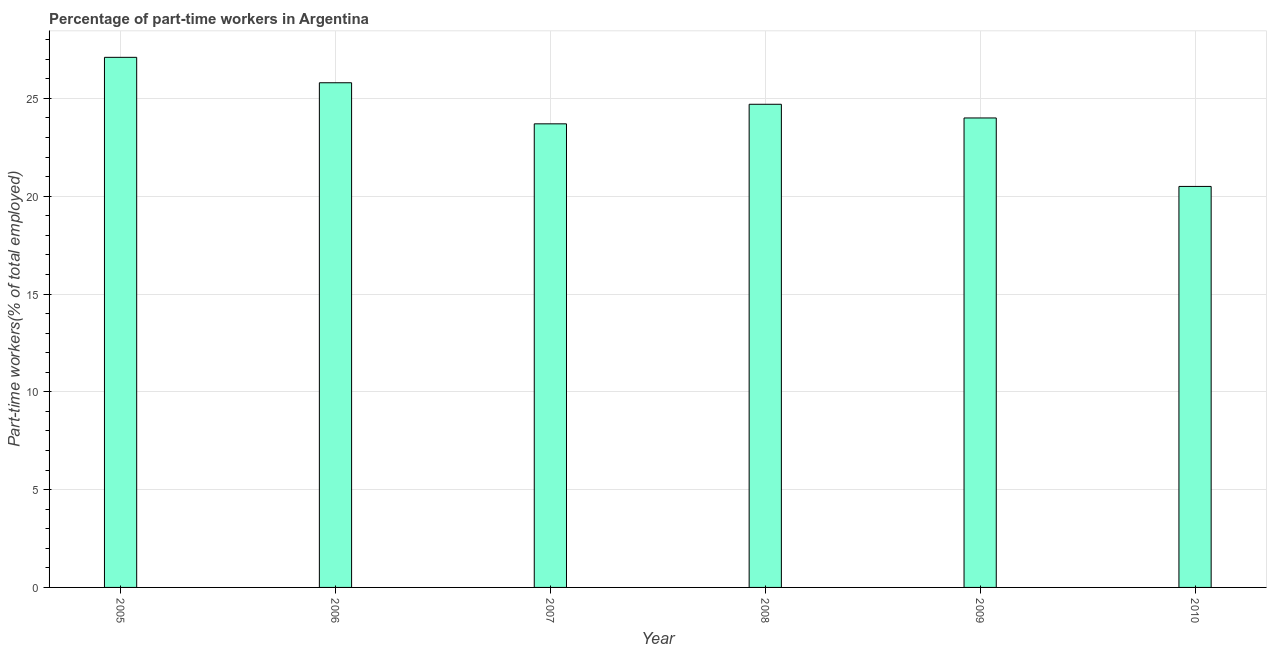Does the graph contain grids?
Make the answer very short. Yes. What is the title of the graph?
Ensure brevity in your answer.  Percentage of part-time workers in Argentina. What is the label or title of the Y-axis?
Offer a terse response. Part-time workers(% of total employed). Across all years, what is the maximum percentage of part-time workers?
Your answer should be very brief. 27.1. Across all years, what is the minimum percentage of part-time workers?
Provide a succinct answer. 20.5. In which year was the percentage of part-time workers maximum?
Give a very brief answer. 2005. In which year was the percentage of part-time workers minimum?
Offer a terse response. 2010. What is the sum of the percentage of part-time workers?
Provide a succinct answer. 145.8. What is the average percentage of part-time workers per year?
Ensure brevity in your answer.  24.3. What is the median percentage of part-time workers?
Make the answer very short. 24.35. In how many years, is the percentage of part-time workers greater than 4 %?
Give a very brief answer. 6. What is the ratio of the percentage of part-time workers in 2006 to that in 2008?
Keep it short and to the point. 1.04. Is the difference between the percentage of part-time workers in 2006 and 2010 greater than the difference between any two years?
Offer a terse response. No. In how many years, is the percentage of part-time workers greater than the average percentage of part-time workers taken over all years?
Ensure brevity in your answer.  3. How many years are there in the graph?
Your answer should be compact. 6. What is the difference between two consecutive major ticks on the Y-axis?
Give a very brief answer. 5. Are the values on the major ticks of Y-axis written in scientific E-notation?
Make the answer very short. No. What is the Part-time workers(% of total employed) of 2005?
Your response must be concise. 27.1. What is the Part-time workers(% of total employed) in 2006?
Your answer should be compact. 25.8. What is the Part-time workers(% of total employed) in 2007?
Provide a short and direct response. 23.7. What is the Part-time workers(% of total employed) of 2008?
Provide a short and direct response. 24.7. What is the Part-time workers(% of total employed) in 2009?
Your answer should be very brief. 24. What is the difference between the Part-time workers(% of total employed) in 2005 and 2006?
Offer a very short reply. 1.3. What is the difference between the Part-time workers(% of total employed) in 2005 and 2008?
Keep it short and to the point. 2.4. What is the difference between the Part-time workers(% of total employed) in 2005 and 2010?
Provide a succinct answer. 6.6. What is the difference between the Part-time workers(% of total employed) in 2006 and 2007?
Offer a terse response. 2.1. What is the difference between the Part-time workers(% of total employed) in 2006 and 2008?
Ensure brevity in your answer.  1.1. What is the difference between the Part-time workers(% of total employed) in 2006 and 2009?
Your answer should be very brief. 1.8. What is the difference between the Part-time workers(% of total employed) in 2006 and 2010?
Offer a terse response. 5.3. What is the difference between the Part-time workers(% of total employed) in 2007 and 2008?
Offer a terse response. -1. What is the difference between the Part-time workers(% of total employed) in 2007 and 2009?
Offer a very short reply. -0.3. What is the difference between the Part-time workers(% of total employed) in 2007 and 2010?
Offer a terse response. 3.2. What is the difference between the Part-time workers(% of total employed) in 2008 and 2009?
Ensure brevity in your answer.  0.7. What is the difference between the Part-time workers(% of total employed) in 2008 and 2010?
Offer a very short reply. 4.2. What is the ratio of the Part-time workers(% of total employed) in 2005 to that in 2007?
Ensure brevity in your answer.  1.14. What is the ratio of the Part-time workers(% of total employed) in 2005 to that in 2008?
Ensure brevity in your answer.  1.1. What is the ratio of the Part-time workers(% of total employed) in 2005 to that in 2009?
Give a very brief answer. 1.13. What is the ratio of the Part-time workers(% of total employed) in 2005 to that in 2010?
Give a very brief answer. 1.32. What is the ratio of the Part-time workers(% of total employed) in 2006 to that in 2007?
Your answer should be compact. 1.09. What is the ratio of the Part-time workers(% of total employed) in 2006 to that in 2008?
Your answer should be compact. 1.04. What is the ratio of the Part-time workers(% of total employed) in 2006 to that in 2009?
Keep it short and to the point. 1.07. What is the ratio of the Part-time workers(% of total employed) in 2006 to that in 2010?
Give a very brief answer. 1.26. What is the ratio of the Part-time workers(% of total employed) in 2007 to that in 2009?
Give a very brief answer. 0.99. What is the ratio of the Part-time workers(% of total employed) in 2007 to that in 2010?
Offer a very short reply. 1.16. What is the ratio of the Part-time workers(% of total employed) in 2008 to that in 2009?
Your response must be concise. 1.03. What is the ratio of the Part-time workers(% of total employed) in 2008 to that in 2010?
Your response must be concise. 1.21. What is the ratio of the Part-time workers(% of total employed) in 2009 to that in 2010?
Your answer should be compact. 1.17. 